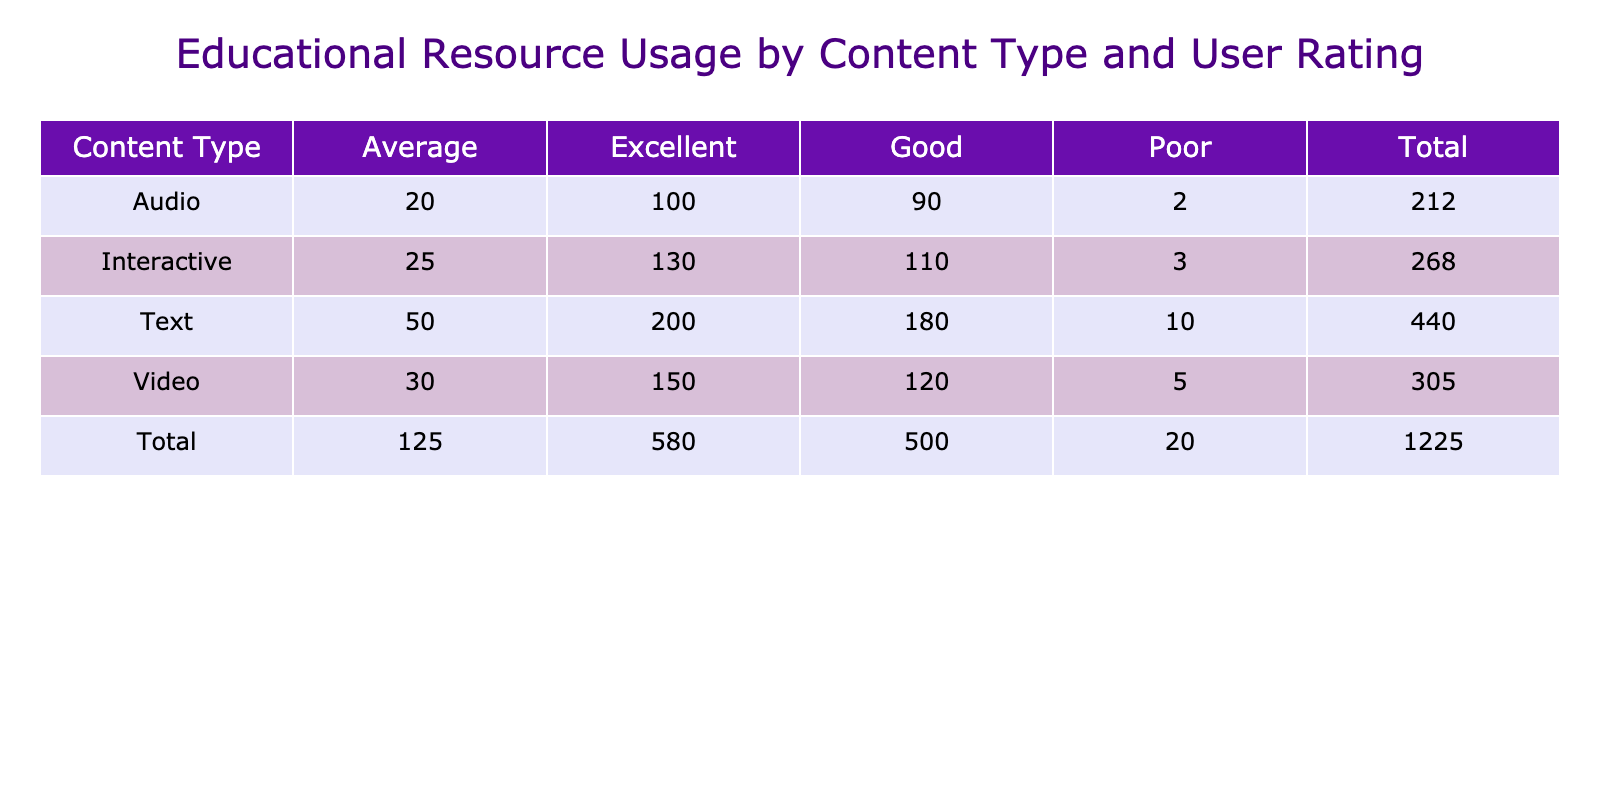What is the total usage count for the Video content type? The usage counts for Video content type are 150 (Excellent) + 120 (Good) + 30 (Average) + 5 (Poor), which sums up to 150 + 120 + 30 + 5 = 305.
Answer: 305 How many resources received a "Poor" rating? The Poor ratings for each content type are as follows: Video 5, Text 10, Interactive 3, and Audio 2. Adding these up: 5 + 10 + 3 + 2 = 20.
Answer: 20 Which content type has the highest usage count for the "Excellent" rating? For the "Excellent" rating, the usage counts are Video 150, Text 200, Interactive 130, and Audio 100. The highest is Text with 200.
Answer: Text Is the total usage count for "Interactive" resources greater than that of "Audio" resources? The total for Interactive = 130 + 110 + 25 + 3 = 268, and for Audio = 100 + 90 + 20 + 2 = 212. Since 268 > 212, the result is true.
Answer: Yes What is the average usage count for the "Good" rating across all content types? The usage counts for the "Good" rating are: Video 120, Text 180, Interactive 110, and Audio 90. To find the average, first sum them: 120 + 180 + 110 + 90 = 500. Then divide by the number of content types (4). So, 500 / 4 = 125.
Answer: 125 What is the difference in usage count between the "Excellent" and "Average" ratings for Text content? The usage count for "Excellent" Text is 200, and for "Average," it is 50. The difference is 200 - 50 = 150.
Answer: 150 Does "Audio" content have any usage count for the "Poor" rating? The usage count for "Poor" under Audio is 2, which indicates that there is usage for this rating.
Answer: Yes Which content type has the lowest total usage count overall? First, calculate the total for each: Video 305, Text 440, Interactive 268, Audio 212. The lowest is Audio with 212.
Answer: Audio 